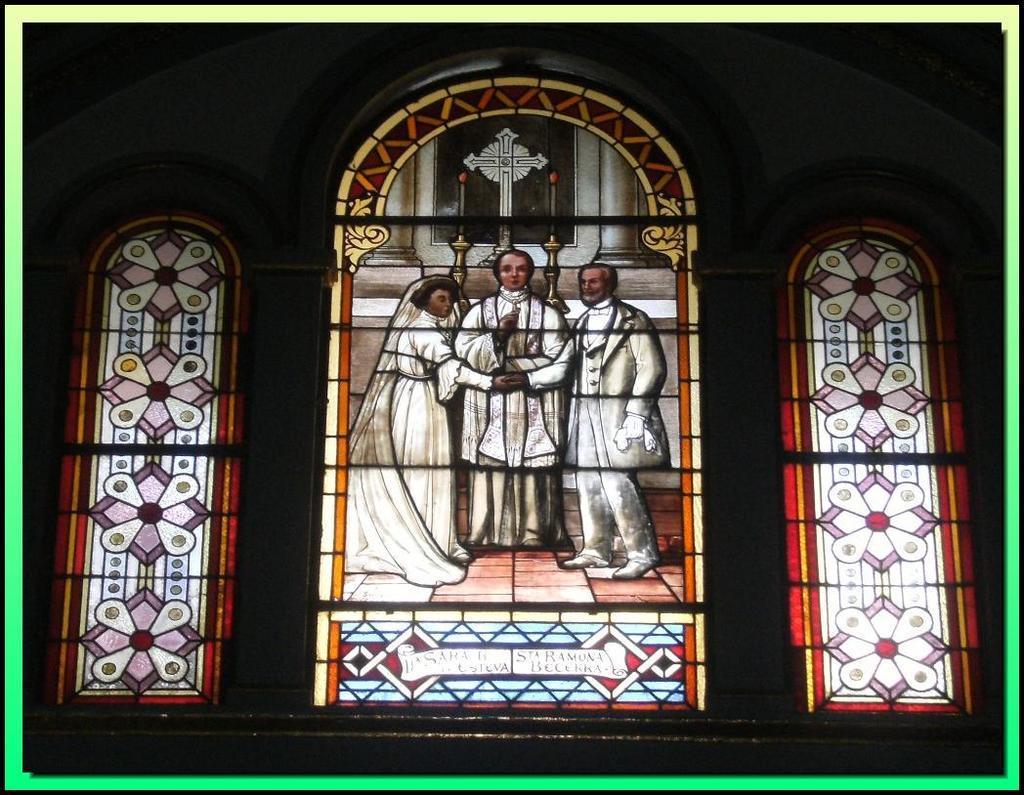Can you describe this image briefly? In the center of the image we can see stained glass windows. 